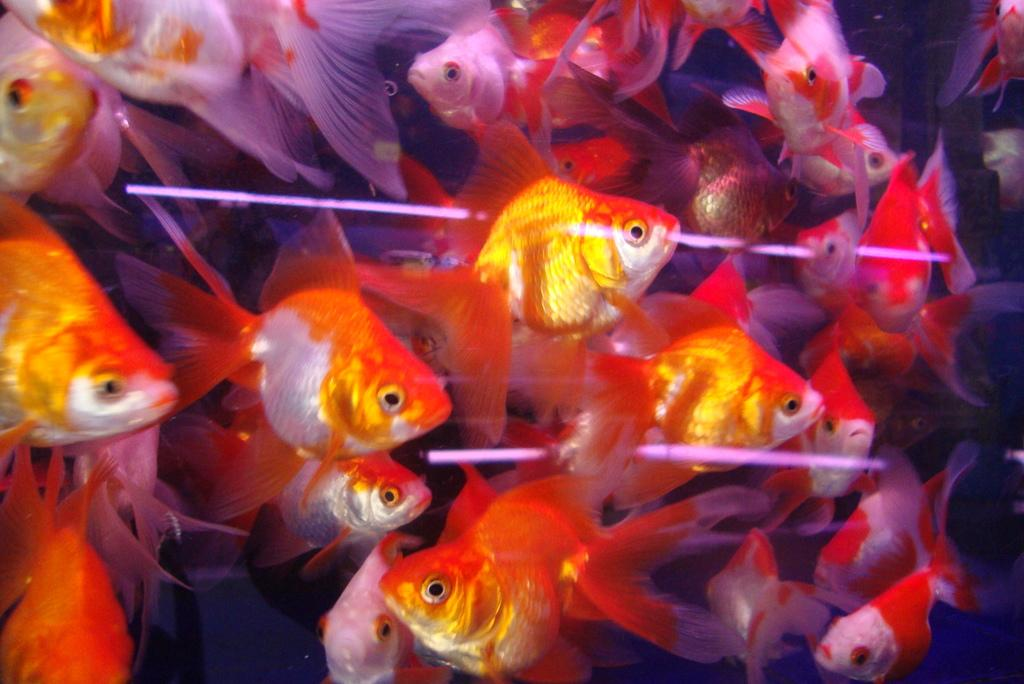What type of animals can be seen in the image? There are fishes in the image. What are the fishes doing in the image? The fishes are swimming in the water. Can you describe the appearance of the fishes? The fishes are of different colors. What type of cable can be seen in the image? There is no cable present in the image; it features fishes swimming in the water. How does the wound on the fish heal in the image? There is no wound on any fish in the image, as they are all swimming without any visible injuries. 